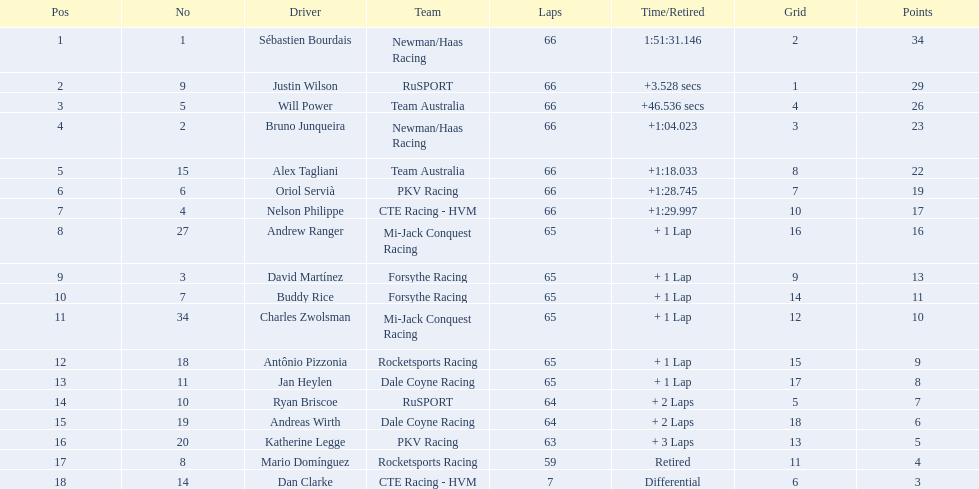Which drivers commenced in the top 10? Sébastien Bourdais, Justin Wilson, Will Power, Bruno Junqueira, Alex Tagliani, Oriol Servià, Nelson Philippe, Ryan Briscoe, Dan Clarke. Which of those drivers accomplished all 66 laps? Sébastien Bourdais, Justin Wilson, Will Power, Bruno Junqueira, Alex Tagliani, Oriol Servià, Nelson Philippe. Who among them did not represent team australia? Sébastien Bourdais, Justin Wilson, Bruno Junqueira, Oriol Servià, Nelson Philippe. Which of these drivers concluded more than a minute after the victor? Bruno Junqueira, Oriol Servià, Nelson Philippe. Which of these drivers had the greatest car number? Oriol Servià. 